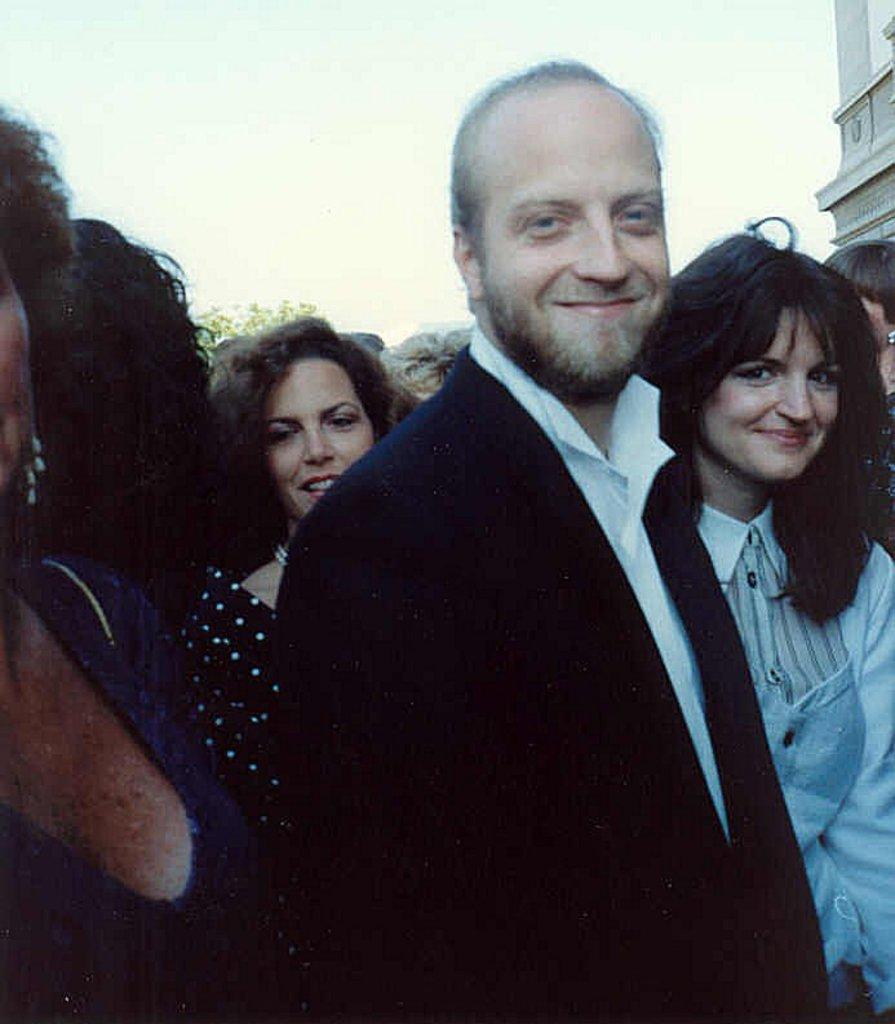Can you describe this image briefly? In this image we can see persons standing on the road. In the background we can see sky and building. 